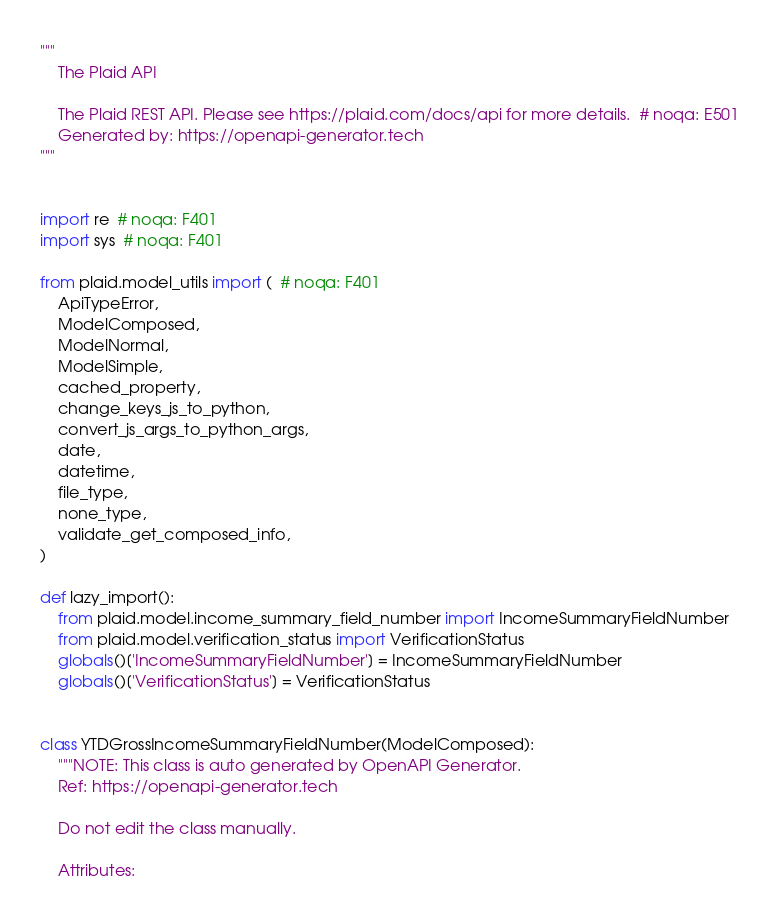<code> <loc_0><loc_0><loc_500><loc_500><_Python_>"""
    The Plaid API

    The Plaid REST API. Please see https://plaid.com/docs/api for more details.  # noqa: E501
    Generated by: https://openapi-generator.tech
"""


import re  # noqa: F401
import sys  # noqa: F401

from plaid.model_utils import (  # noqa: F401
    ApiTypeError,
    ModelComposed,
    ModelNormal,
    ModelSimple,
    cached_property,
    change_keys_js_to_python,
    convert_js_args_to_python_args,
    date,
    datetime,
    file_type,
    none_type,
    validate_get_composed_info,
)

def lazy_import():
    from plaid.model.income_summary_field_number import IncomeSummaryFieldNumber
    from plaid.model.verification_status import VerificationStatus
    globals()['IncomeSummaryFieldNumber'] = IncomeSummaryFieldNumber
    globals()['VerificationStatus'] = VerificationStatus


class YTDGrossIncomeSummaryFieldNumber(ModelComposed):
    """NOTE: This class is auto generated by OpenAPI Generator.
    Ref: https://openapi-generator.tech

    Do not edit the class manually.

    Attributes:</code> 